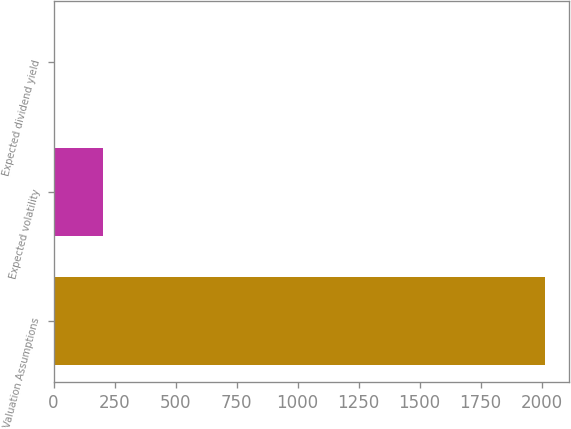Convert chart. <chart><loc_0><loc_0><loc_500><loc_500><bar_chart><fcel>Valuation Assumptions<fcel>Expected volatility<fcel>Expected dividend yield<nl><fcel>2013<fcel>201.41<fcel>0.12<nl></chart> 